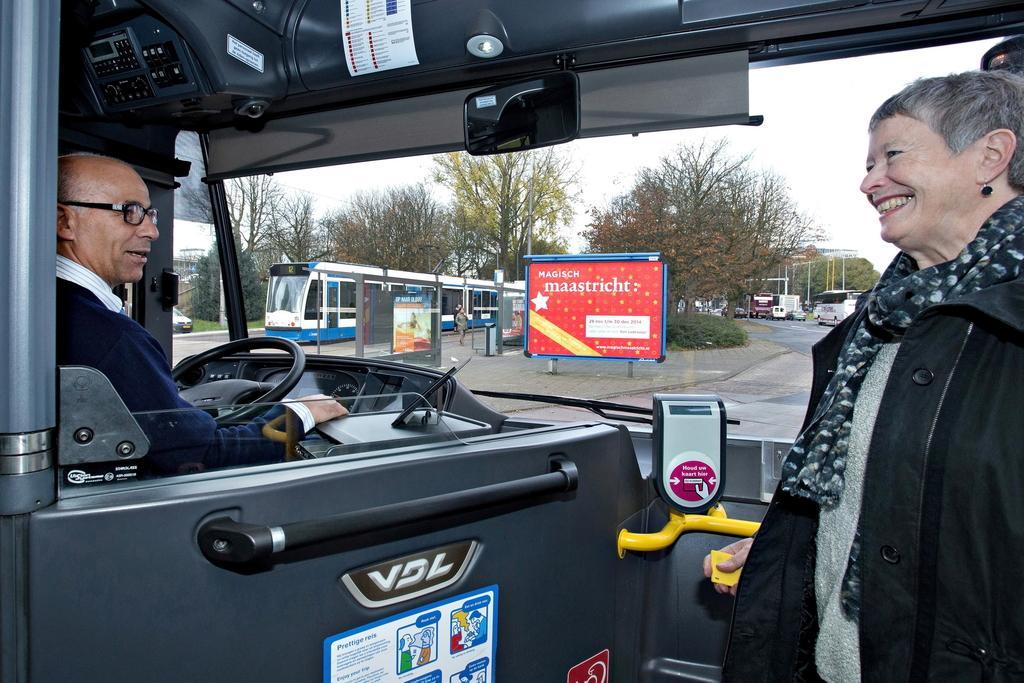How would you summarize this image in a sentence or two? In this image we can see two persons, one of them is driving a bus, there is a train, there are boards with text on them there are vehicles on the road, there are trees, also we can see a poster on the vehicle with text on it, there is a mirror, handle, steering, also we can see the sky. 